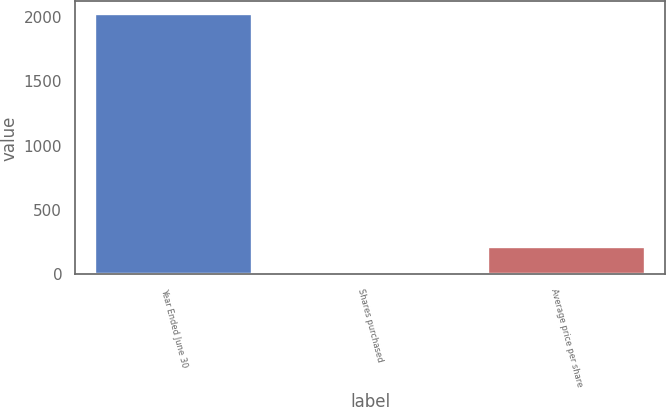Convert chart. <chart><loc_0><loc_0><loc_500><loc_500><bar_chart><fcel>Year Ended June 30<fcel>Shares purchased<fcel>Average price per share<nl><fcel>2018<fcel>13<fcel>213.5<nl></chart> 